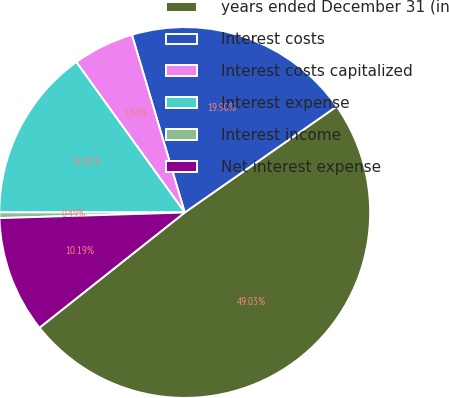Convert chart to OTSL. <chart><loc_0><loc_0><loc_500><loc_500><pie_chart><fcel>years ended December 31 (in<fcel>Interest costs<fcel>Interest costs capitalized<fcel>Interest expense<fcel>Interest income<fcel>Net interest expense<nl><fcel>49.03%<fcel>19.9%<fcel>5.34%<fcel>15.05%<fcel>0.49%<fcel>10.19%<nl></chart> 